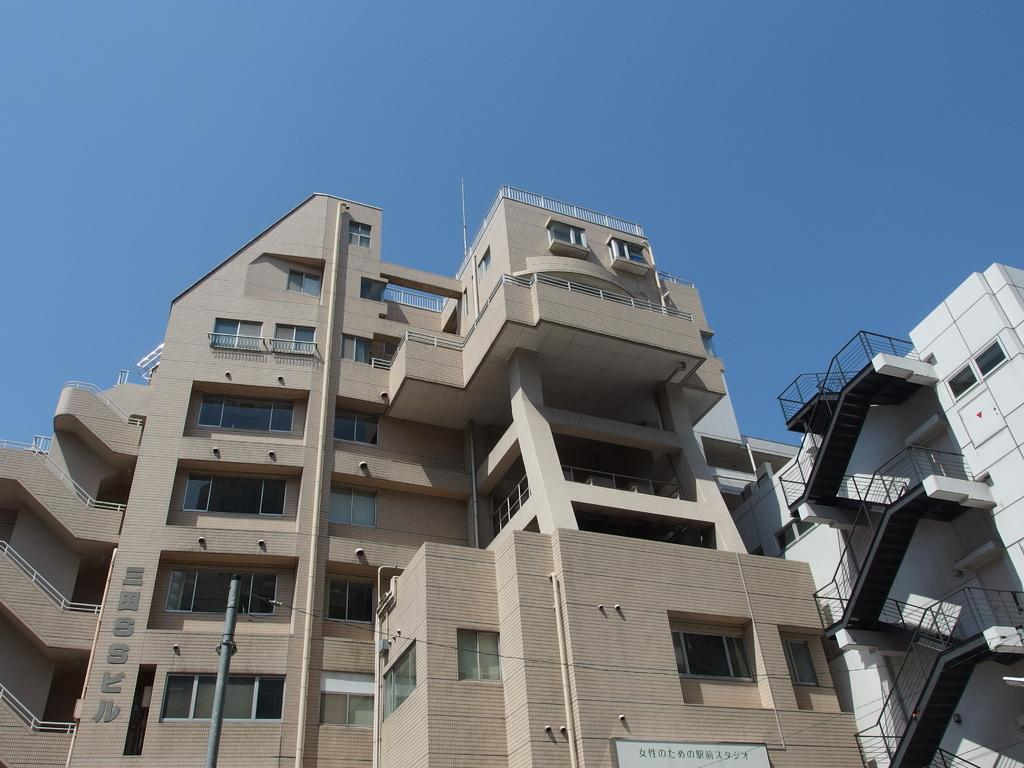What type of structures can be seen in the image? There are buildings in the image. Can you describe any specific features of the buildings? One of the buildings has stairs. What is the condition of the sky in the image? The sky is clear in the image. Can you tell me how many pears are hanging from the clouds in the image? There are no clouds or pears present in the image; it features buildings and a clear sky. What type of medical facility is depicted in the image? There is no hospital or medical facility depicted in the image; it only shows buildings and stairs. 